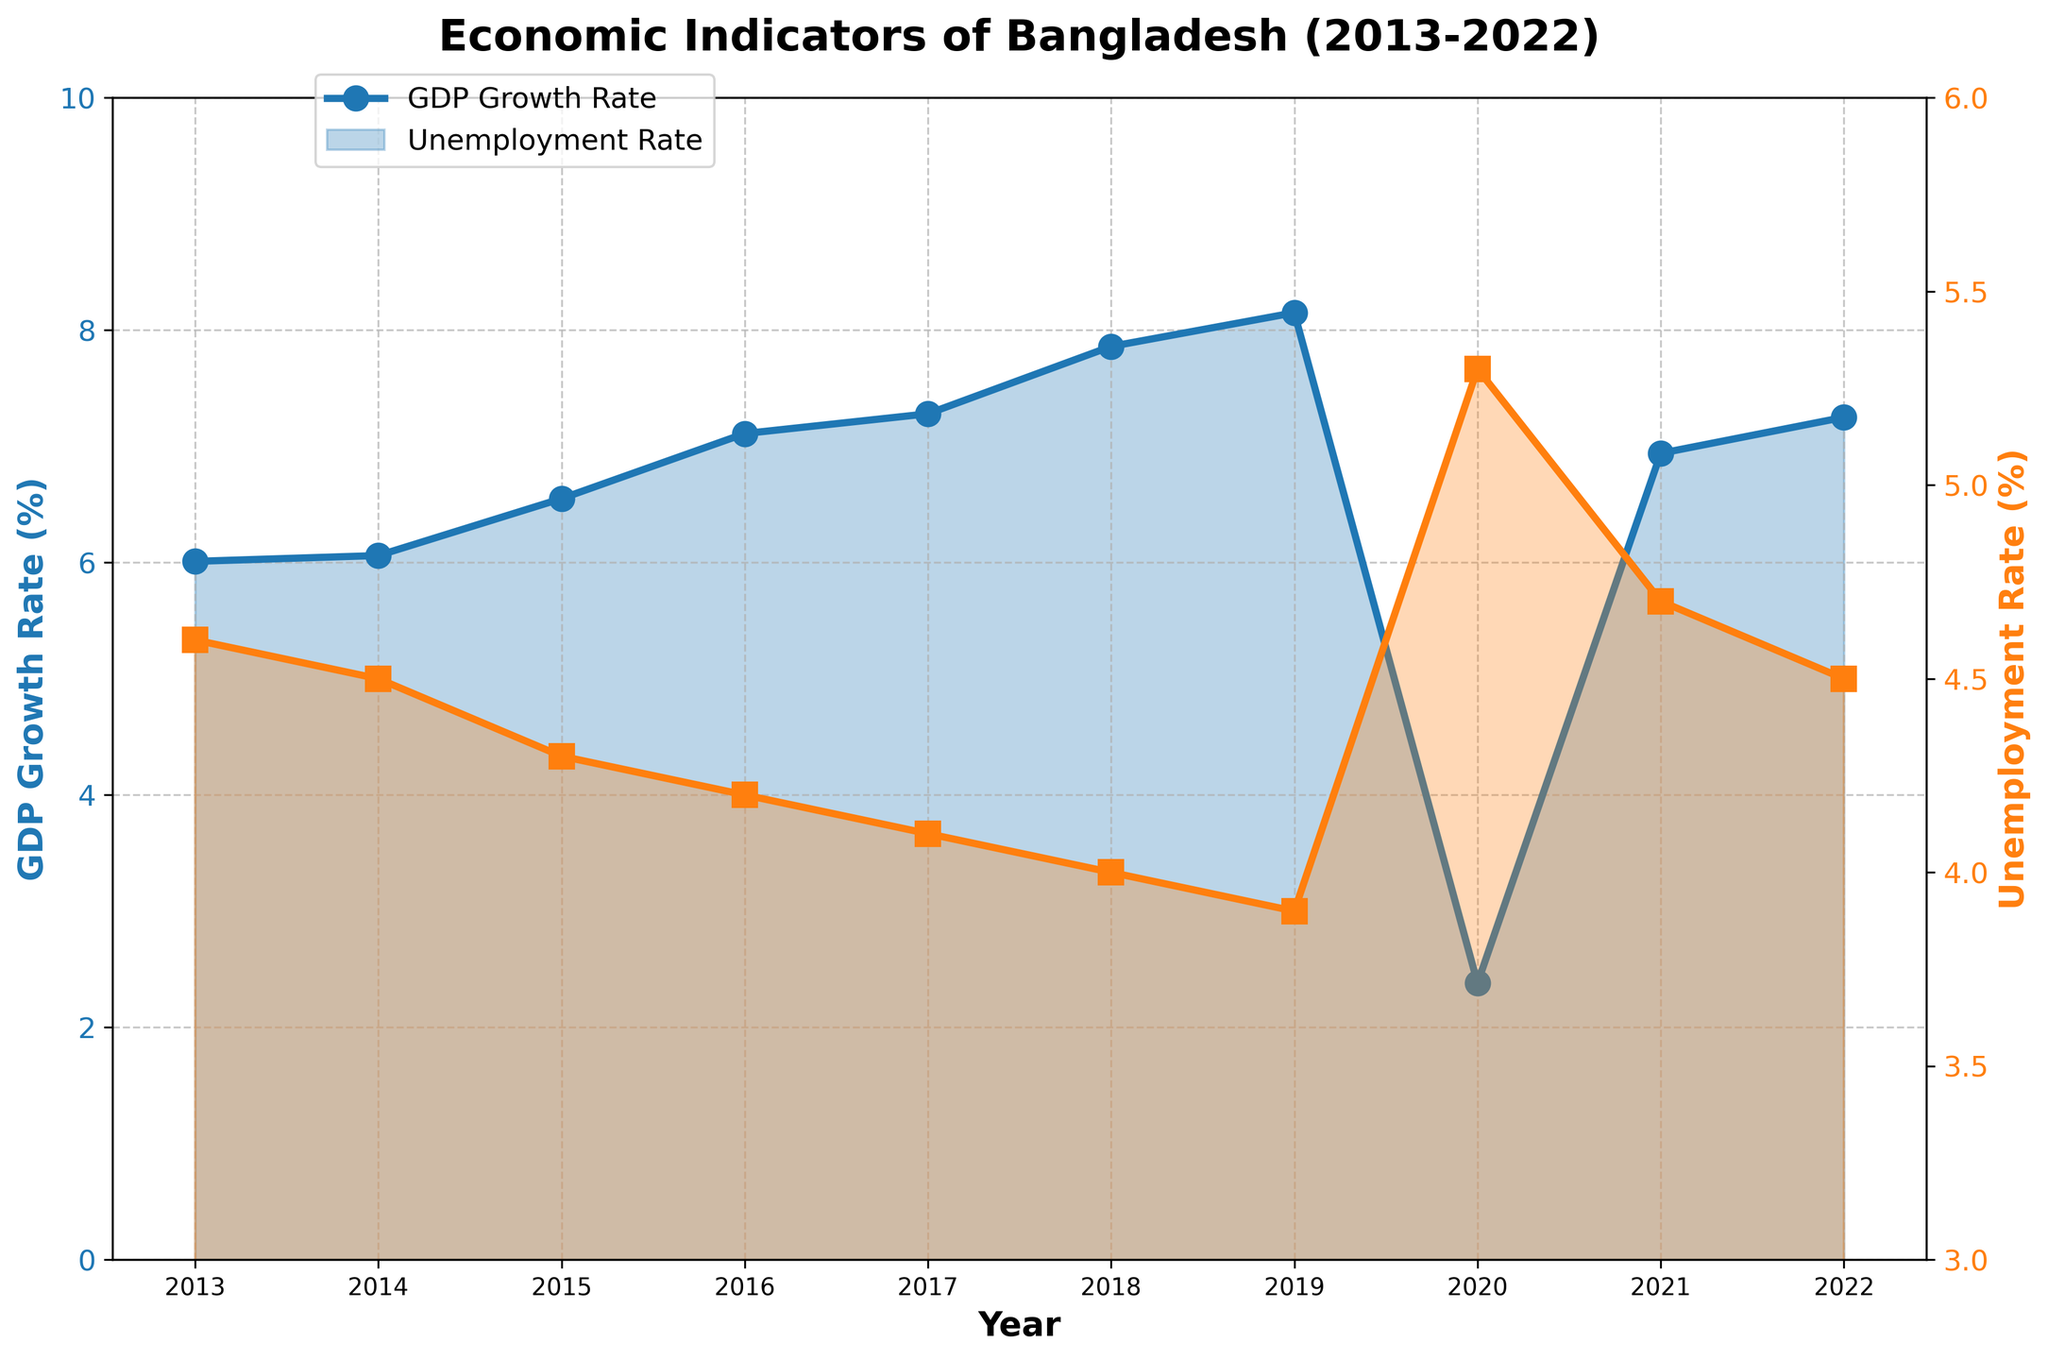What is the title of the plot? The title of the plot is located at the top center and provides an overview of the data represented. In this case, the title is "Economic Indicators of Bangladesh (2013-2022)".
Answer: Economic Indicators of Bangladesh (2013-2022) What is the highest GDP Growth Rate recorded, and in which year did it occur? To find out, look at the GDP growth rate trend line. The highest point on this line is 8.15%, which occurs in the year 2019.
Answer: 8.15% in 2019 In which year did Bangladesh experience the highest unemployment rate, and what was it? By examining the unemployment rate trend line, the peak is observed at 5.3% in the year 2020.
Answer: 5.3% in 2020 How did the GDP Growth Rate and Unemployment Rate change from 2013 to 2014? Compare the values of both indicators between 2013 and 2014. GDP Growth Rate increased from 6.01% to 6.06%, a change of 0.05%. The Unemployment Rate decreased from 4.6% to 4.5%, a change of -0.1%.
Answer: A small increase in GDP Growth Rate by 0.05% and a decrease in Unemployment Rate by -0.1% What was the average GDP Growth Rate from 2016 to 2019? Calculate the average by summing the GDP Growth Rates for 2016 (7.11%), 2017 (7.28%), 2018 (7.86%), and 2019 (8.15%), then divide by 4. The average is (7.11 + 7.28 + 7.86 + 8.15) / 4 = 7.6%.
Answer: 7.6% Compare the GDP Growth Rate and Unemployment Rate for the year 2020. Which one had a more significant change compared to 2019? For GDP Growth Rate, the change from 2019 (8.15%) to 2020 (2.38%) is -5.77%. For Unemployment Rate, the change from 2019 (3.9%) to 2020 (5.3%) is 1.4%. The GDP Growth Rate experienced a more significant change.
Answer: GDP Growth Rate had a more significant change What is the general trend of GDP Growth Rate from 2013 to 2022? Examine the GDP Growth Rate line; it generally increases from 2013 (6.01%) to 2019 (8.15%), then drops in 2020 (2.38%) before rising again to 2022 (7.25%).
Answer: General upward trend with a drop in 2020 In which year did both the GDP Growth Rate and Unemployment Rate show the most significant divergence? The most significant divergence occurs where the GDP Growth Rate peaks and the Unemployment Rate is at its lowest or vice versa. This is in 2019, where GDP Growth Rate is highest at 8.15% and the Unemployment Rate is lowest at 3.9%.
Answer: 2019 What is the total number of data points represented in this plot? Count the number of unique year values along the x-axis. The plot spans from 2013 to 2022, inclusive, thus there are 10 data points.
Answer: 10 How does the Unemployment Rate in 2022 compare to that in 2021? Look at the Unemployment Rate trend for these two years. In 2021, it was 4.7%, and in 2022, it was 4.5%. So, the unemployment rate decreased by 0.2%.
Answer: Decreased by 0.2% 